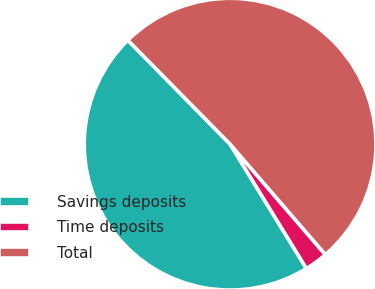Convert chart to OTSL. <chart><loc_0><loc_0><loc_500><loc_500><pie_chart><fcel>Savings deposits<fcel>Time deposits<fcel>Total<nl><fcel>46.4%<fcel>2.57%<fcel>51.04%<nl></chart> 